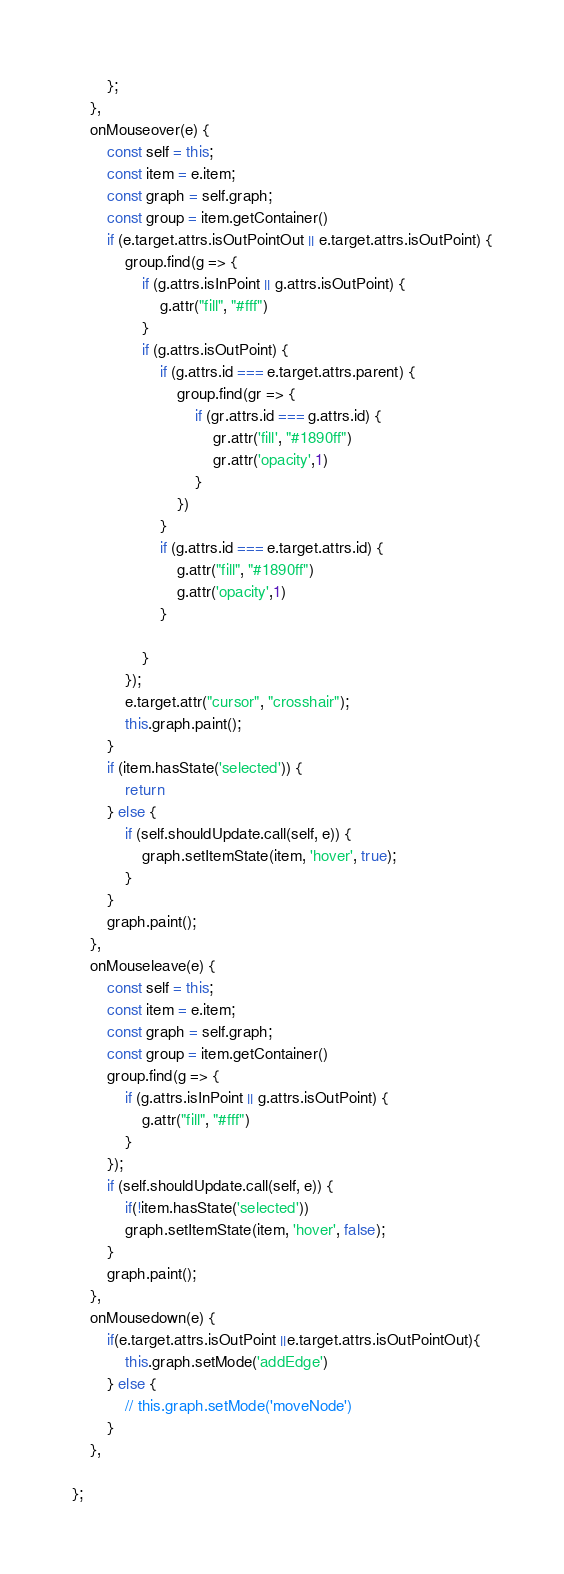Convert code to text. <code><loc_0><loc_0><loc_500><loc_500><_JavaScript_>        };
    },
    onMouseover(e) {
        const self = this;
        const item = e.item;
        const graph = self.graph;
        const group = item.getContainer()
        if (e.target.attrs.isOutPointOut || e.target.attrs.isOutPoint) {
            group.find(g => {
                if (g.attrs.isInPoint || g.attrs.isOutPoint) {
                    g.attr("fill", "#fff")
                }
                if (g.attrs.isOutPoint) {
                    if (g.attrs.id === e.target.attrs.parent) {
                        group.find(gr => {
                            if (gr.attrs.id === g.attrs.id) {
                                gr.attr('fill', "#1890ff")
                                gr.attr('opacity',1)
                            }
                        })
                    }
                    if (g.attrs.id === e.target.attrs.id) {
                        g.attr("fill", "#1890ff")
                        g.attr('opacity',1)
                    }

                }
            });
            e.target.attr("cursor", "crosshair");
            this.graph.paint();
        }
        if (item.hasState('selected')) {
            return
        } else {
            if (self.shouldUpdate.call(self, e)) {
                graph.setItemState(item, 'hover', true);
            }
        }
        graph.paint();
    },
    onMouseleave(e) {
        const self = this;
        const item = e.item;
        const graph = self.graph;
        const group = item.getContainer()
        group.find(g => {
            if (g.attrs.isInPoint || g.attrs.isOutPoint) {
                g.attr("fill", "#fff")
            }
        });
        if (self.shouldUpdate.call(self, e)) {
            if(!item.hasState('selected'))
            graph.setItemState(item, 'hover', false);
        }
        graph.paint();
    },
    onMousedown(e) {
        if(e.target.attrs.isOutPoint ||e.target.attrs.isOutPointOut){
            this.graph.setMode('addEdge')
        } else {
            // this.graph.setMode('moveNode')
        }
    },

};
</code> 